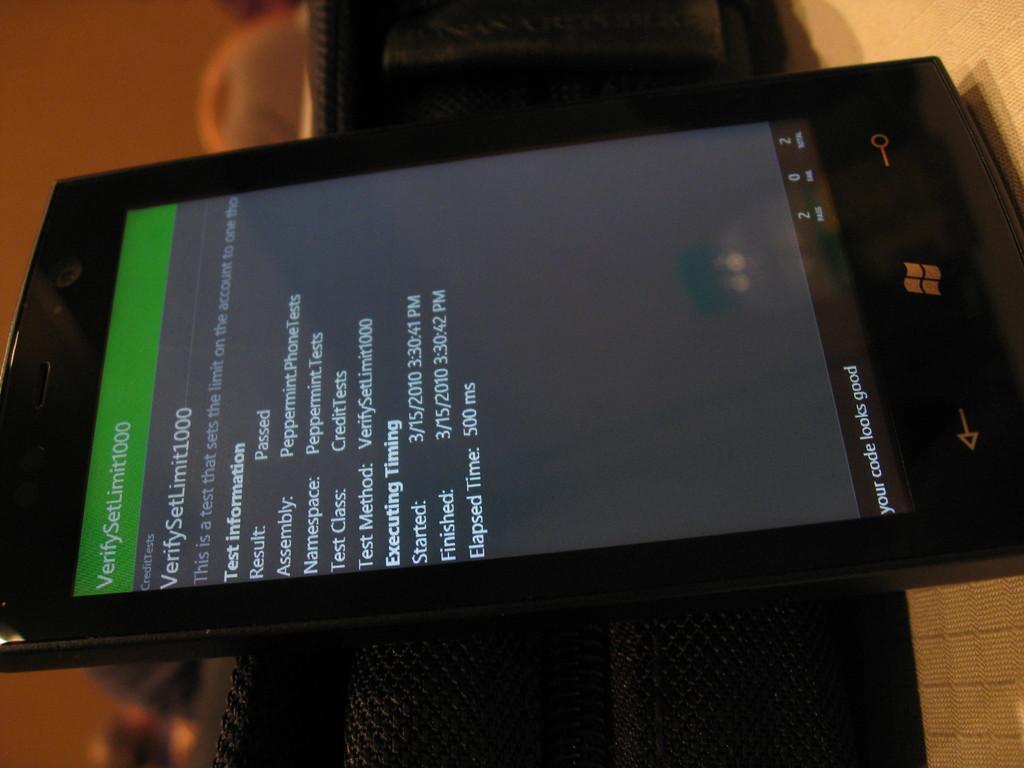What comes after verify?
Your answer should be compact. Setlimit1000. Was the result of the test passed or failed?
Make the answer very short. Passed. 